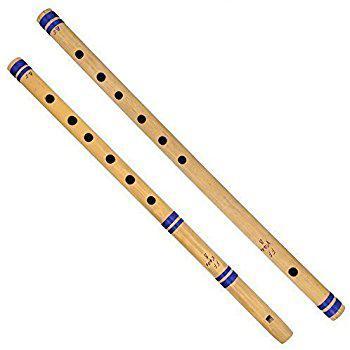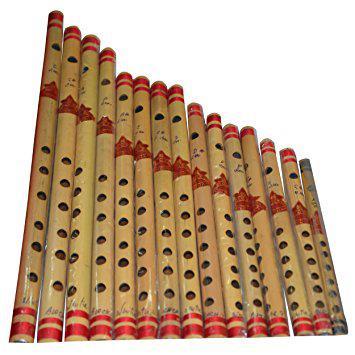The first image is the image on the left, the second image is the image on the right. Evaluate the accuracy of this statement regarding the images: "The right image shows a row of flutes with red stripes arranged in size order, with one end aligned.". Is it true? Answer yes or no. Yes. The first image is the image on the left, the second image is the image on the right. Examine the images to the left and right. Is the description "At least 10 flutes are placed sided by side in each picture." accurate? Answer yes or no. No. 